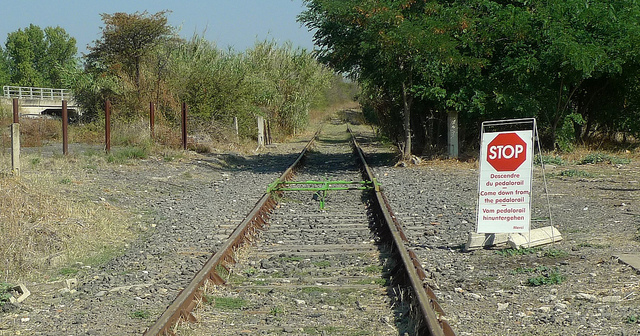Please identify all text content in this image. STOP down 